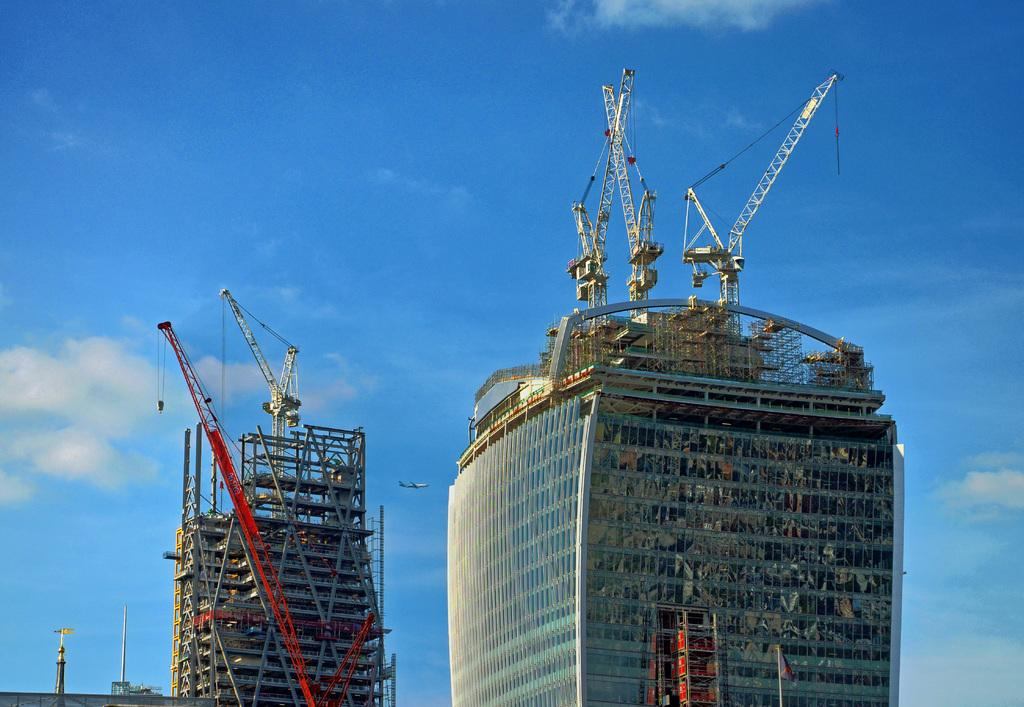What type of structures can be seen in the image? There are buildings in the image. What equipment is present in the image? There are cranes in the image. What other objects can be seen in the image? There are poles in the image. What is visible in the background of the image? The sky is visible in the background of the image. How would you describe the sky in the image? The sky appears to be cloudy. What is the title of the class being taught in the image? There is no class or title present in the image; it features buildings, cranes, poles, and a cloudy sky. 